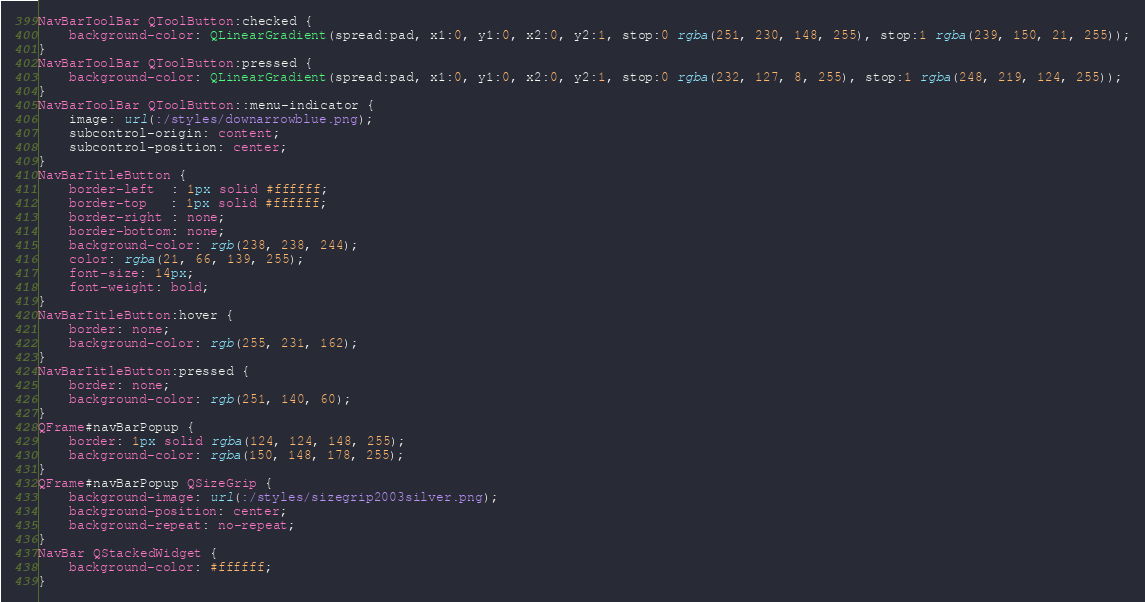Convert code to text. <code><loc_0><loc_0><loc_500><loc_500><_CSS_>NavBarToolBar QToolButton:checked {
    background-color: QLinearGradient(spread:pad, x1:0, y1:0, x2:0, y2:1, stop:0 rgba(251, 230, 148, 255), stop:1 rgba(239, 150, 21, 255));
}
NavBarToolBar QToolButton:pressed {
    background-color: QLinearGradient(spread:pad, x1:0, y1:0, x2:0, y2:1, stop:0 rgba(232, 127, 8, 255), stop:1 rgba(248, 219, 124, 255));
}
NavBarToolBar QToolButton::menu-indicator {
    image: url(:/styles/downarrowblue.png);
    subcontrol-origin: content;
    subcontrol-position: center;
}
NavBarTitleButton {
    border-left  : 1px solid #ffffff;
    border-top   : 1px solid #ffffff;
    border-right : none;
    border-bottom: none;
    background-color: rgb(238, 238, 244);
    color: rgba(21, 66, 139, 255);
    font-size: 14px;
    font-weight: bold;
}
NavBarTitleButton:hover {
    border: none;
    background-color: rgb(255, 231, 162);
}
NavBarTitleButton:pressed {
    border: none;
    background-color: rgb(251, 140, 60);
}
QFrame#navBarPopup {
    border: 1px solid rgba(124, 124, 148, 255);
    background-color: rgba(150, 148, 178, 255);
}
QFrame#navBarPopup QSizeGrip {
    background-image: url(:/styles/sizegrip2003silver.png);
    background-position: center;
    background-repeat: no-repeat;
}
NavBar QStackedWidget {
    background-color: #ffffff;
}
</code> 